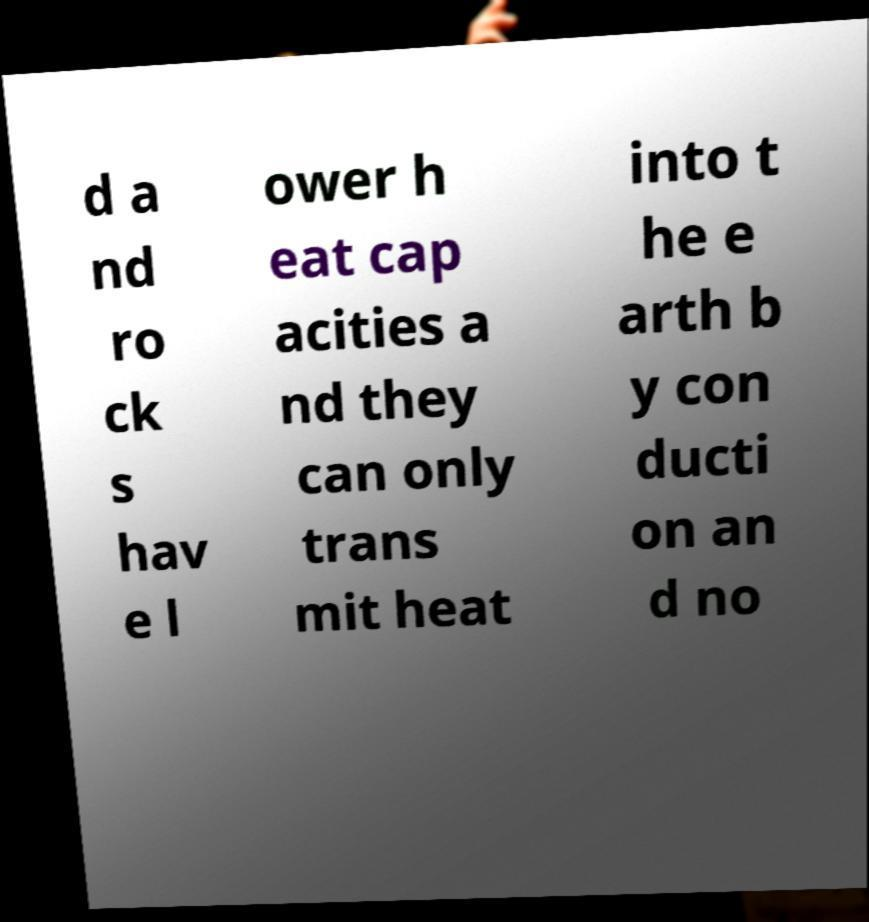Could you extract and type out the text from this image? d a nd ro ck s hav e l ower h eat cap acities a nd they can only trans mit heat into t he e arth b y con ducti on an d no 